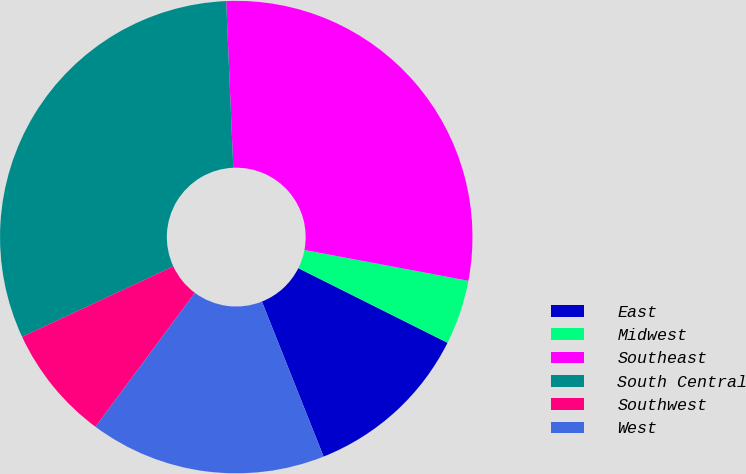Convert chart. <chart><loc_0><loc_0><loc_500><loc_500><pie_chart><fcel>East<fcel>Midwest<fcel>Southeast<fcel>South Central<fcel>Southwest<fcel>West<nl><fcel>11.59%<fcel>4.42%<fcel>28.64%<fcel>31.26%<fcel>7.9%<fcel>16.19%<nl></chart> 